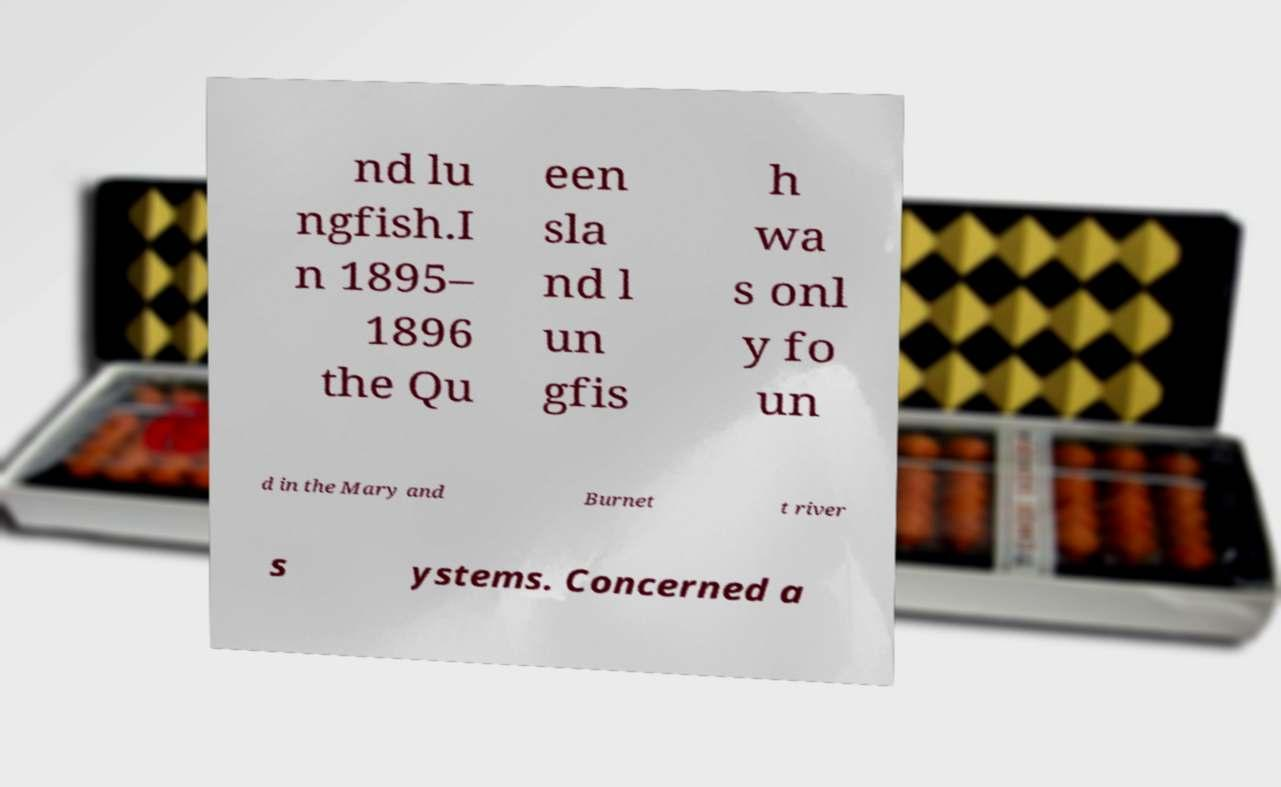Can you accurately transcribe the text from the provided image for me? nd lu ngfish.I n 1895– 1896 the Qu een sla nd l un gfis h wa s onl y fo un d in the Mary and Burnet t river s ystems. Concerned a 